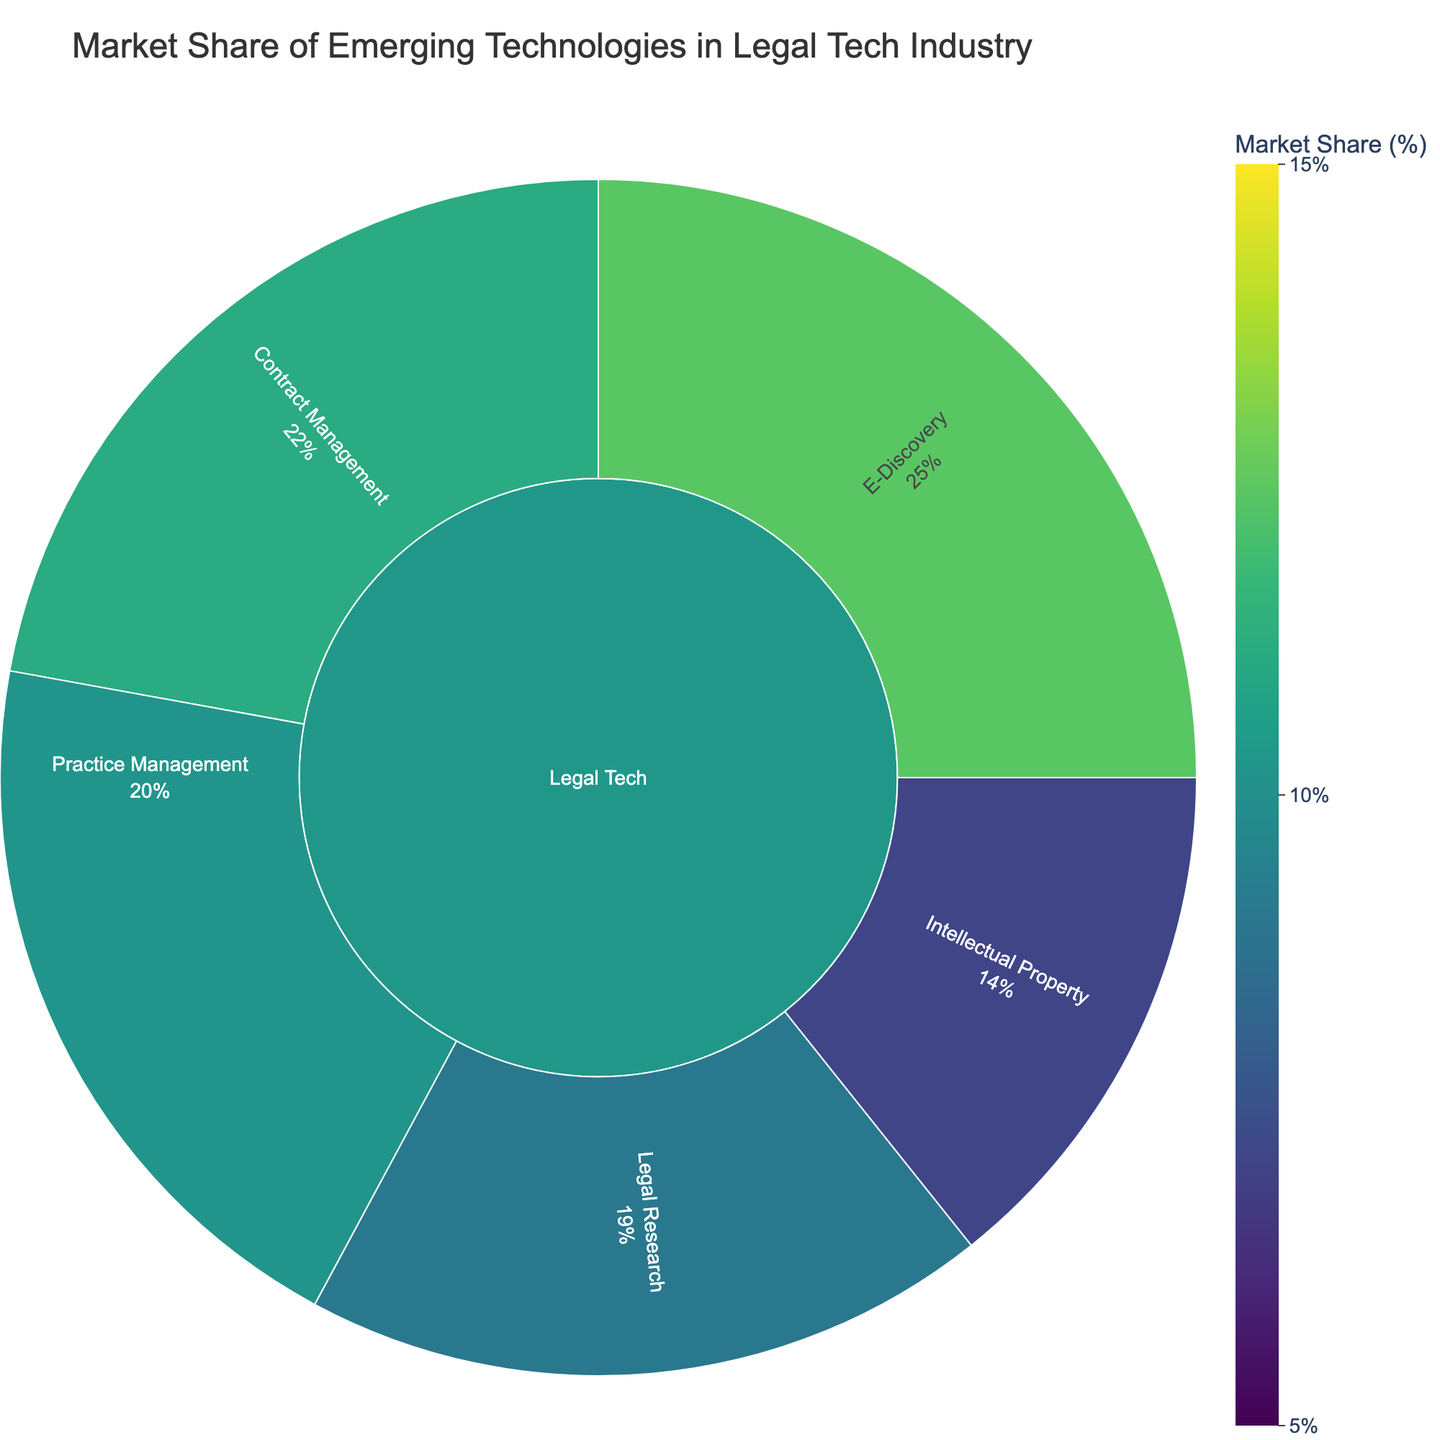What is the market share of AI-Powered Analysis in Contract Management? Look for Contract Management under Legal Tech, and find the subcategory AI-Powered Analysis. The market share value is clearly indicated.
Answer: 14% Which subcategory within E-Discovery has the highest market share? Under E-Discovery in the Legal Tech category, compare the subcategories Predictive Coding, Data Processing, and Early Case Assessment. The highest value is for Predictive Coding.
Answer: Predictive Coding How many subcategories are there under Legal Research, and what is their combined market share? Count the subcategories under Legal Research: AI-Assisted Research, Case Law Analytics, and Regulatory Compliance. Add their market shares: 11 + 8 + 7.
Answer: 3 subcategories, 26% Which subcategory in Practice Management has the lowest market share, and what is the value? Under Practice Management, compare Cloud-Based Solutions, Time Tracking, and Billing Automation. The lowest market share is for Billing Automation.
Answer: Billing Automation, 6% Compare the market share of Predictive Coding in E-Discovery to that of AI-Assisted Research in Legal Research. Which is higher, and by how much? Compare the market shares: Predictive Coding (15) and AI-Assisted Research (11). The difference is 15 - 11 = 4.
Answer: Predictive Coding by 4% In which subcategory under Intellectual Property does Trademark Monitoring fall, and what is its market share? Find Trademark Monitoring under Intellectual Property subcategories. The market share is indicated next to it.
Answer: 6% What is the total market share for all subcategories under Contract Management? Add the market shares of AI-Powered Analysis (14), Automated Drafting (10), and Risk Assessment (7).
Answer: 31% Which category under Legal Tech has the largest total market share, and what is the value? Sum the market shares for each main category (E-Discovery, Contract Management, Practice Management, Legal Research, and Intellectual Property). Compare the totals to find the largest.
Answer: E-Discovery, 35% Which subcategory under Legal Research has the smallest market share, and what is the value? Check the market shares for AI-Assisted Research, Case Law Analytics, and Regulatory Compliance. The smallest is for Regulatory Compliance.
Answer: Regulatory Compliance, 7% How does the market share of E-Discovery's Data Processing compare to Practice Management's Cloud-Based Solutions? Compare the market shares of Data Processing (12) and Cloud-Based Solutions (13). Determine which one is greater.
Answer: Cloud-Based Solutions by 1% 